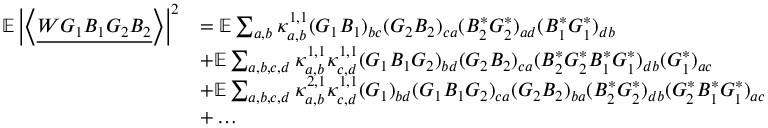<formula> <loc_0><loc_0><loc_500><loc_500>\begin{array} { r l } { \mathbb { E } \left | \left \langle { \underline { { W G _ { 1 } B _ { 1 } G _ { 2 } B _ { 2 } } } } \right \rangle \right | ^ { 2 } } & { = \mathbb { E } \sum _ { a , b } \kappa _ { a , b } ^ { 1 , 1 } ( G _ { 1 } B _ { 1 } ) _ { b c } ( G _ { 2 } B _ { 2 } ) _ { c a } ( B _ { 2 } ^ { * } G _ { 2 } ^ { * } ) _ { a d } ( B _ { 1 } ^ { * } G _ { 1 } ^ { * } ) _ { d b } } \\ & { + \mathbb { E } \sum _ { a , b , c , d } \kappa _ { a , b } ^ { 1 , 1 } \kappa _ { c , d } ^ { 1 , 1 } ( G _ { 1 } B _ { 1 } G _ { 2 } ) _ { b d } ( G _ { 2 } B _ { 2 } ) _ { c a } ( B _ { 2 } ^ { * } G _ { 2 } ^ { * } B _ { 1 } ^ { * } G _ { 1 } ^ { * } ) _ { d b } ( G _ { 1 } ^ { * } ) _ { a c } } \\ & { + \mathbb { E } \sum _ { a , b , c , d } \kappa _ { a , b } ^ { 2 , 1 } \kappa _ { c , d } ^ { 1 , 1 } ( G _ { 1 } ) _ { b d } ( G _ { 1 } B _ { 1 } G _ { 2 } ) _ { c a } ( G _ { 2 } B _ { 2 } ) _ { b a } ( B _ { 2 } ^ { * } G _ { 2 } ^ { * } ) _ { d b } ( G _ { 2 } ^ { * } B _ { 1 } ^ { * } G _ { 1 } ^ { * } ) _ { a c } } \\ & { + \dots } \end{array}</formula> 